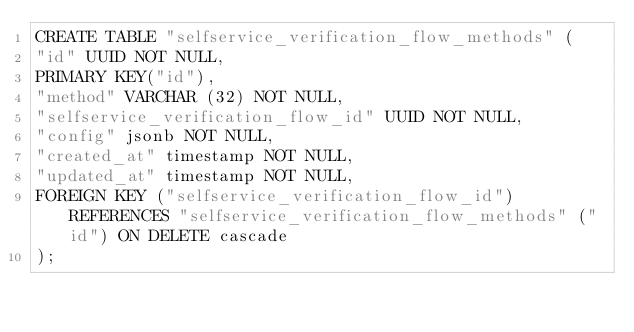Convert code to text. <code><loc_0><loc_0><loc_500><loc_500><_SQL_>CREATE TABLE "selfservice_verification_flow_methods" (
"id" UUID NOT NULL,
PRIMARY KEY("id"),
"method" VARCHAR (32) NOT NULL,
"selfservice_verification_flow_id" UUID NOT NULL,
"config" jsonb NOT NULL,
"created_at" timestamp NOT NULL,
"updated_at" timestamp NOT NULL,
FOREIGN KEY ("selfservice_verification_flow_id") REFERENCES "selfservice_verification_flow_methods" ("id") ON DELETE cascade
);</code> 